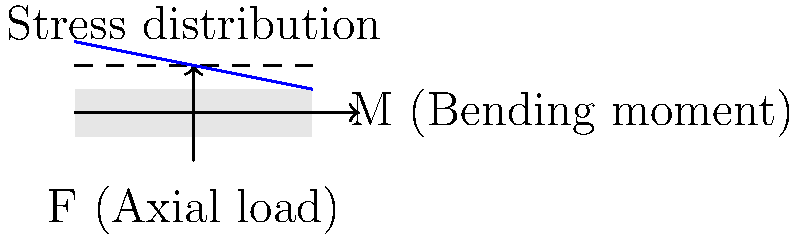In the diagram above, a long bone is subjected to both an axial load (F) and a bending moment (M). How does the combination of these forces affect the stress distribution across the bone's cross-section compared to pure axial loading? Explain the biomechanical principles behind this stress distribution. To understand the stress distribution in this scenario, let's break it down step-by-step:

1. Pure axial loading:
   - Under pure axial loading (F only), the stress would be uniformly distributed across the bone's cross-section.
   - Stress ($\sigma$) would be calculated as $\sigma = \frac{F}{A}$, where A is the cross-sectional area.

2. Pure bending moment:
   - A bending moment (M) alone would create a linear stress distribution.
   - Maximum tensile stress on one side, maximum compressive stress on the other, and a neutral axis in the center.
   - Stress due to bending is calculated using $\sigma = \frac{My}{I}$, where y is the distance from the neutral axis, and I is the moment of inertia.

3. Combined loading:
   - When both axial load (F) and bending moment (M) are applied, we use superposition.
   - The resulting stress distribution is the sum of the stresses from axial loading and bending.
   - $\sigma_{total} = \frac{F}{A} \pm \frac{My}{I}$

4. Effect on stress distribution:
   - The uniform stress from axial loading shifts the entire stress distribution.
   - The linear stress from bending is superimposed on this shifted distribution.
   - Result: An asymmetric, non-uniform stress distribution across the bone's cross-section.

5. Biomechanical implications:
   - This combined loading creates areas of higher stress concentration.
   - The side experiencing tensile stress from bending will have higher total stress.
   - This stress distribution is crucial for understanding bone remodeling and fracture risk.

The blue line in the diagram represents this non-uniform stress distribution resulting from the combined loading.
Answer: Non-uniform, asymmetric stress distribution with higher stress on the tensile side. 